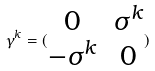<formula> <loc_0><loc_0><loc_500><loc_500>\gamma ^ { k } = ( \begin{matrix} 0 & \sigma ^ { k } \\ - \sigma ^ { k } & 0 \end{matrix} )</formula> 